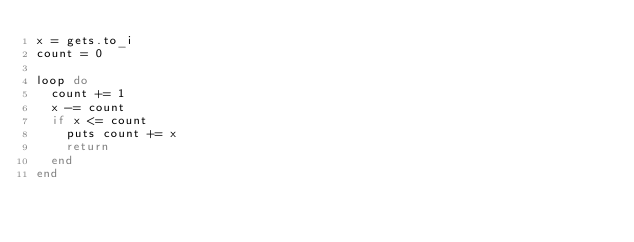<code> <loc_0><loc_0><loc_500><loc_500><_Ruby_>x = gets.to_i
count = 0

loop do
  count += 1
  x -= count
  if x <= count
    puts count += x
    return
  end
end
</code> 